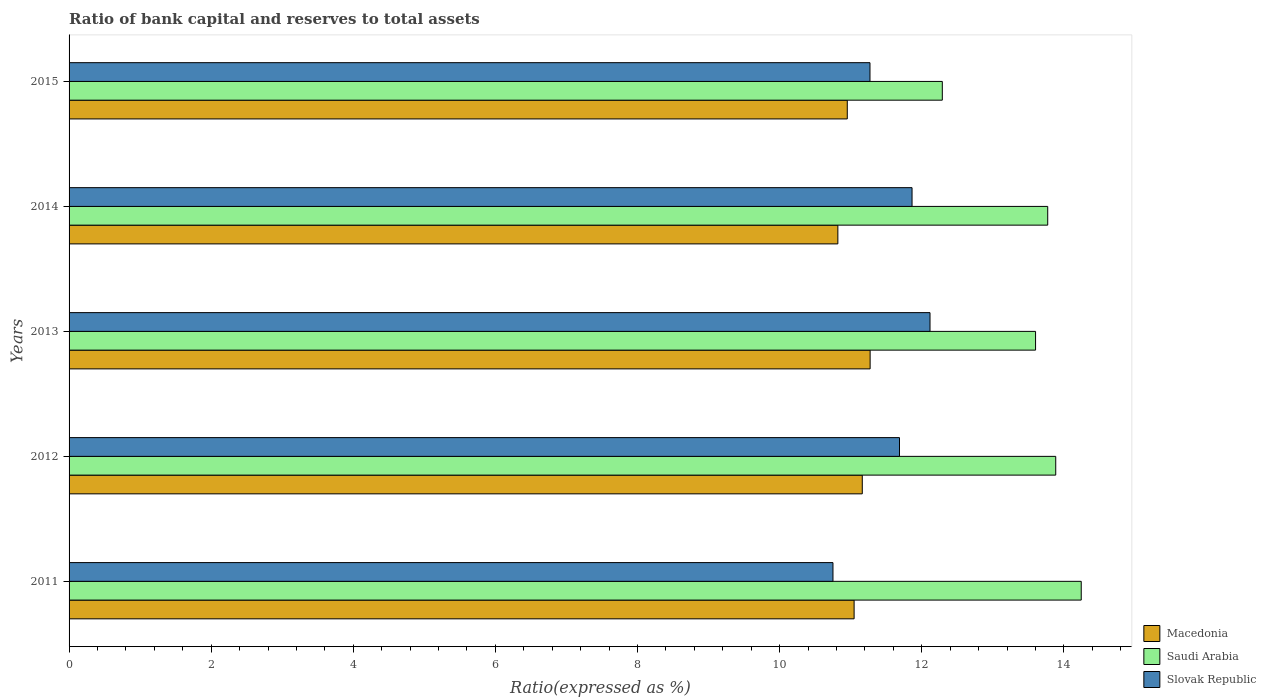How many different coloured bars are there?
Offer a very short reply. 3. How many groups of bars are there?
Your answer should be very brief. 5. How many bars are there on the 2nd tick from the bottom?
Offer a very short reply. 3. What is the label of the 2nd group of bars from the top?
Provide a succinct answer. 2014. In how many cases, is the number of bars for a given year not equal to the number of legend labels?
Make the answer very short. 0. What is the ratio of bank capital and reserves to total assets in Slovak Republic in 2011?
Your answer should be very brief. 10.75. Across all years, what is the maximum ratio of bank capital and reserves to total assets in Saudi Arabia?
Provide a succinct answer. 14.24. Across all years, what is the minimum ratio of bank capital and reserves to total assets in Saudi Arabia?
Your answer should be very brief. 12.29. What is the total ratio of bank capital and reserves to total assets in Saudi Arabia in the graph?
Provide a succinct answer. 67.8. What is the difference between the ratio of bank capital and reserves to total assets in Saudi Arabia in 2011 and that in 2012?
Make the answer very short. 0.36. What is the difference between the ratio of bank capital and reserves to total assets in Macedonia in 2014 and the ratio of bank capital and reserves to total assets in Slovak Republic in 2015?
Ensure brevity in your answer.  -0.45. What is the average ratio of bank capital and reserves to total assets in Saudi Arabia per year?
Your response must be concise. 13.56. In the year 2015, what is the difference between the ratio of bank capital and reserves to total assets in Saudi Arabia and ratio of bank capital and reserves to total assets in Macedonia?
Keep it short and to the point. 1.34. In how many years, is the ratio of bank capital and reserves to total assets in Saudi Arabia greater than 10.4 %?
Make the answer very short. 5. What is the ratio of the ratio of bank capital and reserves to total assets in Slovak Republic in 2011 to that in 2013?
Make the answer very short. 0.89. Is the difference between the ratio of bank capital and reserves to total assets in Saudi Arabia in 2012 and 2014 greater than the difference between the ratio of bank capital and reserves to total assets in Macedonia in 2012 and 2014?
Offer a terse response. No. What is the difference between the highest and the second highest ratio of bank capital and reserves to total assets in Macedonia?
Keep it short and to the point. 0.11. What is the difference between the highest and the lowest ratio of bank capital and reserves to total assets in Slovak Republic?
Offer a very short reply. 1.37. What does the 1st bar from the top in 2012 represents?
Your answer should be very brief. Slovak Republic. What does the 2nd bar from the bottom in 2014 represents?
Offer a very short reply. Saudi Arabia. Is it the case that in every year, the sum of the ratio of bank capital and reserves to total assets in Slovak Republic and ratio of bank capital and reserves to total assets in Saudi Arabia is greater than the ratio of bank capital and reserves to total assets in Macedonia?
Your answer should be compact. Yes. What is the difference between two consecutive major ticks on the X-axis?
Offer a terse response. 2. Are the values on the major ticks of X-axis written in scientific E-notation?
Your answer should be very brief. No. How many legend labels are there?
Ensure brevity in your answer.  3. How are the legend labels stacked?
Provide a short and direct response. Vertical. What is the title of the graph?
Provide a short and direct response. Ratio of bank capital and reserves to total assets. Does "Iceland" appear as one of the legend labels in the graph?
Ensure brevity in your answer.  No. What is the label or title of the X-axis?
Your answer should be very brief. Ratio(expressed as %). What is the label or title of the Y-axis?
Ensure brevity in your answer.  Years. What is the Ratio(expressed as %) in Macedonia in 2011?
Provide a succinct answer. 11.05. What is the Ratio(expressed as %) in Saudi Arabia in 2011?
Your answer should be very brief. 14.24. What is the Ratio(expressed as %) in Slovak Republic in 2011?
Ensure brevity in your answer.  10.75. What is the Ratio(expressed as %) in Macedonia in 2012?
Ensure brevity in your answer.  11.16. What is the Ratio(expressed as %) of Saudi Arabia in 2012?
Give a very brief answer. 13.89. What is the Ratio(expressed as %) of Slovak Republic in 2012?
Provide a short and direct response. 11.69. What is the Ratio(expressed as %) of Macedonia in 2013?
Offer a terse response. 11.27. What is the Ratio(expressed as %) in Saudi Arabia in 2013?
Keep it short and to the point. 13.6. What is the Ratio(expressed as %) in Slovak Republic in 2013?
Your answer should be very brief. 12.12. What is the Ratio(expressed as %) of Macedonia in 2014?
Keep it short and to the point. 10.82. What is the Ratio(expressed as %) of Saudi Arabia in 2014?
Offer a very short reply. 13.77. What is the Ratio(expressed as %) in Slovak Republic in 2014?
Provide a succinct answer. 11.86. What is the Ratio(expressed as %) of Macedonia in 2015?
Provide a short and direct response. 10.95. What is the Ratio(expressed as %) of Saudi Arabia in 2015?
Offer a very short reply. 12.29. What is the Ratio(expressed as %) of Slovak Republic in 2015?
Your answer should be compact. 11.27. Across all years, what is the maximum Ratio(expressed as %) in Macedonia?
Keep it short and to the point. 11.27. Across all years, what is the maximum Ratio(expressed as %) in Saudi Arabia?
Ensure brevity in your answer.  14.24. Across all years, what is the maximum Ratio(expressed as %) of Slovak Republic?
Offer a terse response. 12.12. Across all years, what is the minimum Ratio(expressed as %) in Macedonia?
Ensure brevity in your answer.  10.82. Across all years, what is the minimum Ratio(expressed as %) in Saudi Arabia?
Your response must be concise. 12.29. Across all years, what is the minimum Ratio(expressed as %) in Slovak Republic?
Provide a succinct answer. 10.75. What is the total Ratio(expressed as %) in Macedonia in the graph?
Offer a terse response. 55.26. What is the total Ratio(expressed as %) of Saudi Arabia in the graph?
Keep it short and to the point. 67.8. What is the total Ratio(expressed as %) in Slovak Republic in the graph?
Your answer should be compact. 57.69. What is the difference between the Ratio(expressed as %) of Macedonia in 2011 and that in 2012?
Your answer should be compact. -0.12. What is the difference between the Ratio(expressed as %) of Saudi Arabia in 2011 and that in 2012?
Your answer should be compact. 0.36. What is the difference between the Ratio(expressed as %) in Slovak Republic in 2011 and that in 2012?
Your response must be concise. -0.94. What is the difference between the Ratio(expressed as %) of Macedonia in 2011 and that in 2013?
Ensure brevity in your answer.  -0.23. What is the difference between the Ratio(expressed as %) in Saudi Arabia in 2011 and that in 2013?
Give a very brief answer. 0.64. What is the difference between the Ratio(expressed as %) in Slovak Republic in 2011 and that in 2013?
Your answer should be compact. -1.37. What is the difference between the Ratio(expressed as %) in Macedonia in 2011 and that in 2014?
Your answer should be compact. 0.23. What is the difference between the Ratio(expressed as %) of Saudi Arabia in 2011 and that in 2014?
Your response must be concise. 0.47. What is the difference between the Ratio(expressed as %) of Slovak Republic in 2011 and that in 2014?
Provide a short and direct response. -1.11. What is the difference between the Ratio(expressed as %) in Macedonia in 2011 and that in 2015?
Your answer should be very brief. 0.1. What is the difference between the Ratio(expressed as %) in Saudi Arabia in 2011 and that in 2015?
Make the answer very short. 1.96. What is the difference between the Ratio(expressed as %) in Slovak Republic in 2011 and that in 2015?
Make the answer very short. -0.52. What is the difference between the Ratio(expressed as %) in Macedonia in 2012 and that in 2013?
Ensure brevity in your answer.  -0.11. What is the difference between the Ratio(expressed as %) of Saudi Arabia in 2012 and that in 2013?
Make the answer very short. 0.28. What is the difference between the Ratio(expressed as %) of Slovak Republic in 2012 and that in 2013?
Ensure brevity in your answer.  -0.43. What is the difference between the Ratio(expressed as %) of Macedonia in 2012 and that in 2014?
Your answer should be compact. 0.34. What is the difference between the Ratio(expressed as %) of Saudi Arabia in 2012 and that in 2014?
Offer a very short reply. 0.11. What is the difference between the Ratio(expressed as %) of Slovak Republic in 2012 and that in 2014?
Provide a short and direct response. -0.18. What is the difference between the Ratio(expressed as %) in Macedonia in 2012 and that in 2015?
Your answer should be compact. 0.21. What is the difference between the Ratio(expressed as %) of Saudi Arabia in 2012 and that in 2015?
Give a very brief answer. 1.6. What is the difference between the Ratio(expressed as %) of Slovak Republic in 2012 and that in 2015?
Provide a succinct answer. 0.42. What is the difference between the Ratio(expressed as %) of Macedonia in 2013 and that in 2014?
Offer a very short reply. 0.45. What is the difference between the Ratio(expressed as %) in Saudi Arabia in 2013 and that in 2014?
Your answer should be compact. -0.17. What is the difference between the Ratio(expressed as %) of Slovak Republic in 2013 and that in 2014?
Provide a succinct answer. 0.25. What is the difference between the Ratio(expressed as %) in Macedonia in 2013 and that in 2015?
Your response must be concise. 0.32. What is the difference between the Ratio(expressed as %) in Saudi Arabia in 2013 and that in 2015?
Your answer should be very brief. 1.31. What is the difference between the Ratio(expressed as %) of Slovak Republic in 2013 and that in 2015?
Provide a succinct answer. 0.84. What is the difference between the Ratio(expressed as %) of Macedonia in 2014 and that in 2015?
Your answer should be very brief. -0.13. What is the difference between the Ratio(expressed as %) in Saudi Arabia in 2014 and that in 2015?
Offer a very short reply. 1.48. What is the difference between the Ratio(expressed as %) of Slovak Republic in 2014 and that in 2015?
Ensure brevity in your answer.  0.59. What is the difference between the Ratio(expressed as %) of Macedonia in 2011 and the Ratio(expressed as %) of Saudi Arabia in 2012?
Offer a very short reply. -2.84. What is the difference between the Ratio(expressed as %) of Macedonia in 2011 and the Ratio(expressed as %) of Slovak Republic in 2012?
Your response must be concise. -0.64. What is the difference between the Ratio(expressed as %) of Saudi Arabia in 2011 and the Ratio(expressed as %) of Slovak Republic in 2012?
Offer a terse response. 2.56. What is the difference between the Ratio(expressed as %) in Macedonia in 2011 and the Ratio(expressed as %) in Saudi Arabia in 2013?
Give a very brief answer. -2.55. What is the difference between the Ratio(expressed as %) of Macedonia in 2011 and the Ratio(expressed as %) of Slovak Republic in 2013?
Provide a short and direct response. -1.07. What is the difference between the Ratio(expressed as %) of Saudi Arabia in 2011 and the Ratio(expressed as %) of Slovak Republic in 2013?
Give a very brief answer. 2.13. What is the difference between the Ratio(expressed as %) in Macedonia in 2011 and the Ratio(expressed as %) in Saudi Arabia in 2014?
Keep it short and to the point. -2.72. What is the difference between the Ratio(expressed as %) in Macedonia in 2011 and the Ratio(expressed as %) in Slovak Republic in 2014?
Ensure brevity in your answer.  -0.82. What is the difference between the Ratio(expressed as %) in Saudi Arabia in 2011 and the Ratio(expressed as %) in Slovak Republic in 2014?
Provide a succinct answer. 2.38. What is the difference between the Ratio(expressed as %) in Macedonia in 2011 and the Ratio(expressed as %) in Saudi Arabia in 2015?
Offer a very short reply. -1.24. What is the difference between the Ratio(expressed as %) in Macedonia in 2011 and the Ratio(expressed as %) in Slovak Republic in 2015?
Your response must be concise. -0.22. What is the difference between the Ratio(expressed as %) in Saudi Arabia in 2011 and the Ratio(expressed as %) in Slovak Republic in 2015?
Make the answer very short. 2.97. What is the difference between the Ratio(expressed as %) of Macedonia in 2012 and the Ratio(expressed as %) of Saudi Arabia in 2013?
Your response must be concise. -2.44. What is the difference between the Ratio(expressed as %) of Macedonia in 2012 and the Ratio(expressed as %) of Slovak Republic in 2013?
Offer a terse response. -0.95. What is the difference between the Ratio(expressed as %) of Saudi Arabia in 2012 and the Ratio(expressed as %) of Slovak Republic in 2013?
Provide a short and direct response. 1.77. What is the difference between the Ratio(expressed as %) in Macedonia in 2012 and the Ratio(expressed as %) in Saudi Arabia in 2014?
Give a very brief answer. -2.61. What is the difference between the Ratio(expressed as %) of Macedonia in 2012 and the Ratio(expressed as %) of Slovak Republic in 2014?
Offer a very short reply. -0.7. What is the difference between the Ratio(expressed as %) of Saudi Arabia in 2012 and the Ratio(expressed as %) of Slovak Republic in 2014?
Your answer should be compact. 2.02. What is the difference between the Ratio(expressed as %) of Macedonia in 2012 and the Ratio(expressed as %) of Saudi Arabia in 2015?
Provide a short and direct response. -1.13. What is the difference between the Ratio(expressed as %) of Macedonia in 2012 and the Ratio(expressed as %) of Slovak Republic in 2015?
Offer a terse response. -0.11. What is the difference between the Ratio(expressed as %) in Saudi Arabia in 2012 and the Ratio(expressed as %) in Slovak Republic in 2015?
Offer a very short reply. 2.61. What is the difference between the Ratio(expressed as %) in Macedonia in 2013 and the Ratio(expressed as %) in Saudi Arabia in 2014?
Your answer should be compact. -2.5. What is the difference between the Ratio(expressed as %) in Macedonia in 2013 and the Ratio(expressed as %) in Slovak Republic in 2014?
Ensure brevity in your answer.  -0.59. What is the difference between the Ratio(expressed as %) in Saudi Arabia in 2013 and the Ratio(expressed as %) in Slovak Republic in 2014?
Provide a succinct answer. 1.74. What is the difference between the Ratio(expressed as %) in Macedonia in 2013 and the Ratio(expressed as %) in Saudi Arabia in 2015?
Your answer should be very brief. -1.02. What is the difference between the Ratio(expressed as %) of Macedonia in 2013 and the Ratio(expressed as %) of Slovak Republic in 2015?
Make the answer very short. 0. What is the difference between the Ratio(expressed as %) of Saudi Arabia in 2013 and the Ratio(expressed as %) of Slovak Republic in 2015?
Your response must be concise. 2.33. What is the difference between the Ratio(expressed as %) of Macedonia in 2014 and the Ratio(expressed as %) of Saudi Arabia in 2015?
Make the answer very short. -1.47. What is the difference between the Ratio(expressed as %) of Macedonia in 2014 and the Ratio(expressed as %) of Slovak Republic in 2015?
Your answer should be very brief. -0.45. What is the difference between the Ratio(expressed as %) of Saudi Arabia in 2014 and the Ratio(expressed as %) of Slovak Republic in 2015?
Make the answer very short. 2.5. What is the average Ratio(expressed as %) of Macedonia per year?
Offer a very short reply. 11.05. What is the average Ratio(expressed as %) in Saudi Arabia per year?
Your response must be concise. 13.56. What is the average Ratio(expressed as %) in Slovak Republic per year?
Give a very brief answer. 11.54. In the year 2011, what is the difference between the Ratio(expressed as %) of Macedonia and Ratio(expressed as %) of Saudi Arabia?
Make the answer very short. -3.2. In the year 2011, what is the difference between the Ratio(expressed as %) in Macedonia and Ratio(expressed as %) in Slovak Republic?
Keep it short and to the point. 0.3. In the year 2011, what is the difference between the Ratio(expressed as %) in Saudi Arabia and Ratio(expressed as %) in Slovak Republic?
Ensure brevity in your answer.  3.49. In the year 2012, what is the difference between the Ratio(expressed as %) of Macedonia and Ratio(expressed as %) of Saudi Arabia?
Make the answer very short. -2.72. In the year 2012, what is the difference between the Ratio(expressed as %) of Macedonia and Ratio(expressed as %) of Slovak Republic?
Offer a very short reply. -0.52. In the year 2012, what is the difference between the Ratio(expressed as %) in Saudi Arabia and Ratio(expressed as %) in Slovak Republic?
Give a very brief answer. 2.2. In the year 2013, what is the difference between the Ratio(expressed as %) of Macedonia and Ratio(expressed as %) of Saudi Arabia?
Your response must be concise. -2.33. In the year 2013, what is the difference between the Ratio(expressed as %) in Macedonia and Ratio(expressed as %) in Slovak Republic?
Give a very brief answer. -0.84. In the year 2013, what is the difference between the Ratio(expressed as %) in Saudi Arabia and Ratio(expressed as %) in Slovak Republic?
Your answer should be very brief. 1.49. In the year 2014, what is the difference between the Ratio(expressed as %) of Macedonia and Ratio(expressed as %) of Saudi Arabia?
Keep it short and to the point. -2.95. In the year 2014, what is the difference between the Ratio(expressed as %) in Macedonia and Ratio(expressed as %) in Slovak Republic?
Offer a very short reply. -1.04. In the year 2014, what is the difference between the Ratio(expressed as %) in Saudi Arabia and Ratio(expressed as %) in Slovak Republic?
Ensure brevity in your answer.  1.91. In the year 2015, what is the difference between the Ratio(expressed as %) in Macedonia and Ratio(expressed as %) in Saudi Arabia?
Your response must be concise. -1.34. In the year 2015, what is the difference between the Ratio(expressed as %) in Macedonia and Ratio(expressed as %) in Slovak Republic?
Keep it short and to the point. -0.32. In the year 2015, what is the difference between the Ratio(expressed as %) of Saudi Arabia and Ratio(expressed as %) of Slovak Republic?
Ensure brevity in your answer.  1.02. What is the ratio of the Ratio(expressed as %) in Macedonia in 2011 to that in 2012?
Your answer should be very brief. 0.99. What is the ratio of the Ratio(expressed as %) in Saudi Arabia in 2011 to that in 2012?
Your response must be concise. 1.03. What is the ratio of the Ratio(expressed as %) of Slovak Republic in 2011 to that in 2012?
Your answer should be compact. 0.92. What is the ratio of the Ratio(expressed as %) in Saudi Arabia in 2011 to that in 2013?
Make the answer very short. 1.05. What is the ratio of the Ratio(expressed as %) in Slovak Republic in 2011 to that in 2013?
Your response must be concise. 0.89. What is the ratio of the Ratio(expressed as %) in Macedonia in 2011 to that in 2014?
Provide a short and direct response. 1.02. What is the ratio of the Ratio(expressed as %) of Saudi Arabia in 2011 to that in 2014?
Offer a very short reply. 1.03. What is the ratio of the Ratio(expressed as %) in Slovak Republic in 2011 to that in 2014?
Ensure brevity in your answer.  0.91. What is the ratio of the Ratio(expressed as %) in Macedonia in 2011 to that in 2015?
Offer a terse response. 1.01. What is the ratio of the Ratio(expressed as %) in Saudi Arabia in 2011 to that in 2015?
Give a very brief answer. 1.16. What is the ratio of the Ratio(expressed as %) in Slovak Republic in 2011 to that in 2015?
Provide a succinct answer. 0.95. What is the ratio of the Ratio(expressed as %) of Macedonia in 2012 to that in 2013?
Provide a succinct answer. 0.99. What is the ratio of the Ratio(expressed as %) in Saudi Arabia in 2012 to that in 2013?
Keep it short and to the point. 1.02. What is the ratio of the Ratio(expressed as %) in Slovak Republic in 2012 to that in 2013?
Keep it short and to the point. 0.96. What is the ratio of the Ratio(expressed as %) in Macedonia in 2012 to that in 2014?
Offer a very short reply. 1.03. What is the ratio of the Ratio(expressed as %) in Saudi Arabia in 2012 to that in 2014?
Provide a succinct answer. 1.01. What is the ratio of the Ratio(expressed as %) in Slovak Republic in 2012 to that in 2014?
Offer a terse response. 0.99. What is the ratio of the Ratio(expressed as %) of Macedonia in 2012 to that in 2015?
Your answer should be compact. 1.02. What is the ratio of the Ratio(expressed as %) in Saudi Arabia in 2012 to that in 2015?
Give a very brief answer. 1.13. What is the ratio of the Ratio(expressed as %) of Slovak Republic in 2012 to that in 2015?
Give a very brief answer. 1.04. What is the ratio of the Ratio(expressed as %) in Macedonia in 2013 to that in 2014?
Your response must be concise. 1.04. What is the ratio of the Ratio(expressed as %) of Saudi Arabia in 2013 to that in 2014?
Your response must be concise. 0.99. What is the ratio of the Ratio(expressed as %) in Slovak Republic in 2013 to that in 2014?
Provide a short and direct response. 1.02. What is the ratio of the Ratio(expressed as %) of Macedonia in 2013 to that in 2015?
Give a very brief answer. 1.03. What is the ratio of the Ratio(expressed as %) in Saudi Arabia in 2013 to that in 2015?
Your answer should be compact. 1.11. What is the ratio of the Ratio(expressed as %) of Slovak Republic in 2013 to that in 2015?
Provide a short and direct response. 1.07. What is the ratio of the Ratio(expressed as %) in Macedonia in 2014 to that in 2015?
Provide a succinct answer. 0.99. What is the ratio of the Ratio(expressed as %) of Saudi Arabia in 2014 to that in 2015?
Provide a short and direct response. 1.12. What is the ratio of the Ratio(expressed as %) in Slovak Republic in 2014 to that in 2015?
Your answer should be very brief. 1.05. What is the difference between the highest and the second highest Ratio(expressed as %) of Macedonia?
Your answer should be very brief. 0.11. What is the difference between the highest and the second highest Ratio(expressed as %) in Saudi Arabia?
Keep it short and to the point. 0.36. What is the difference between the highest and the second highest Ratio(expressed as %) of Slovak Republic?
Offer a very short reply. 0.25. What is the difference between the highest and the lowest Ratio(expressed as %) of Macedonia?
Provide a short and direct response. 0.45. What is the difference between the highest and the lowest Ratio(expressed as %) of Saudi Arabia?
Keep it short and to the point. 1.96. What is the difference between the highest and the lowest Ratio(expressed as %) of Slovak Republic?
Your answer should be very brief. 1.37. 